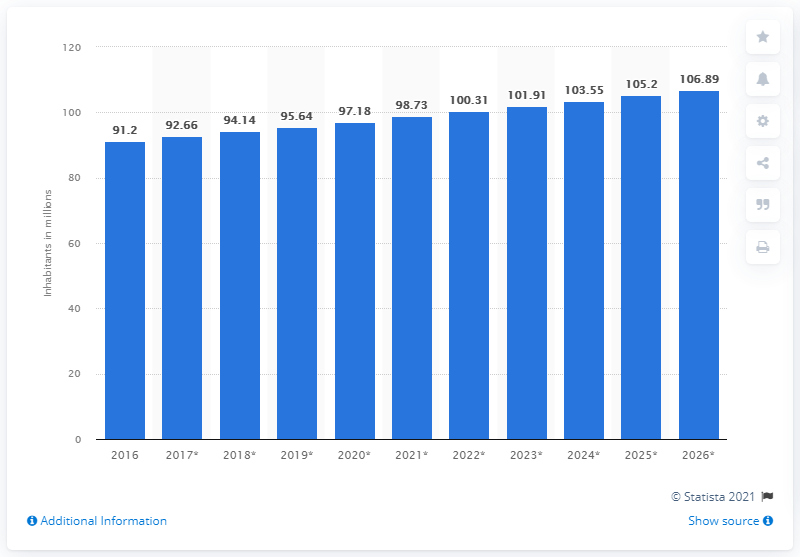Draw attention to some important aspects in this diagram. In 2016, the population of Ethiopia was 91.2 million. 